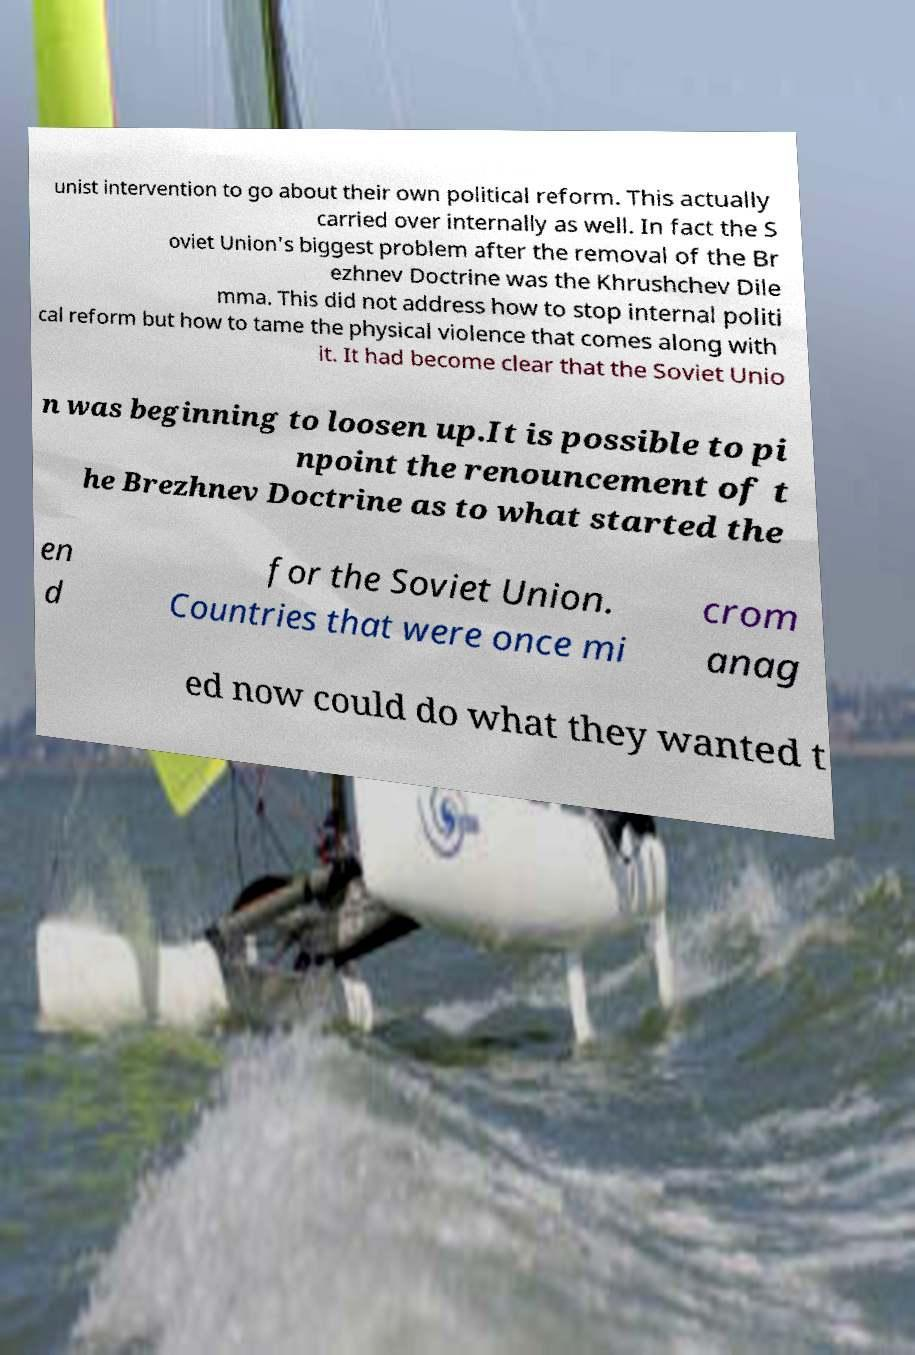What messages or text are displayed in this image? I need them in a readable, typed format. unist intervention to go about their own political reform. This actually carried over internally as well. In fact the S oviet Union's biggest problem after the removal of the Br ezhnev Doctrine was the Khrushchev Dile mma. This did not address how to stop internal politi cal reform but how to tame the physical violence that comes along with it. It had become clear that the Soviet Unio n was beginning to loosen up.It is possible to pi npoint the renouncement of t he Brezhnev Doctrine as to what started the en d for the Soviet Union. Countries that were once mi crom anag ed now could do what they wanted t 